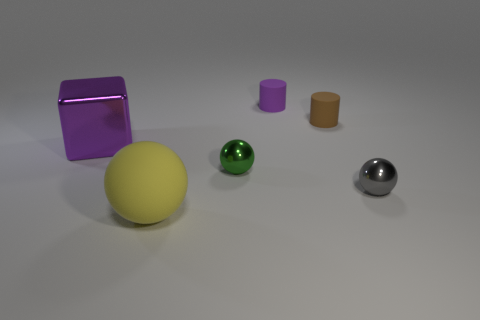There is another small object that is the same shape as the purple matte object; what is its material?
Offer a terse response. Rubber. Is there anything else that has the same size as the metal cube?
Offer a terse response. Yes. There is a tiny matte thing in front of the purple cylinder; is it the same shape as the purple object on the left side of the green sphere?
Your answer should be very brief. No. Are there fewer brown rubber objects in front of the large sphere than yellow balls behind the big purple shiny block?
Offer a terse response. No. What number of other objects are the same shape as the purple matte object?
Provide a short and direct response. 1. The large object that is made of the same material as the green ball is what shape?
Offer a terse response. Cube. There is a thing that is on the right side of the tiny purple matte thing and in front of the purple metallic object; what color is it?
Your answer should be very brief. Gray. Does the tiny object that is on the right side of the small brown rubber cylinder have the same material as the big cube?
Offer a very short reply. Yes. Is the number of large yellow rubber objects that are behind the purple cylinder less than the number of purple cylinders?
Your answer should be very brief. Yes. Are there any other small gray spheres made of the same material as the gray ball?
Offer a terse response. No. 